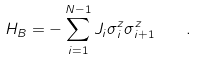Convert formula to latex. <formula><loc_0><loc_0><loc_500><loc_500>H _ { B } = - \sum _ { i = 1 } ^ { N - 1 } J _ { i } \sigma _ { i } ^ { z } \sigma _ { i + 1 } ^ { z } \quad .</formula> 